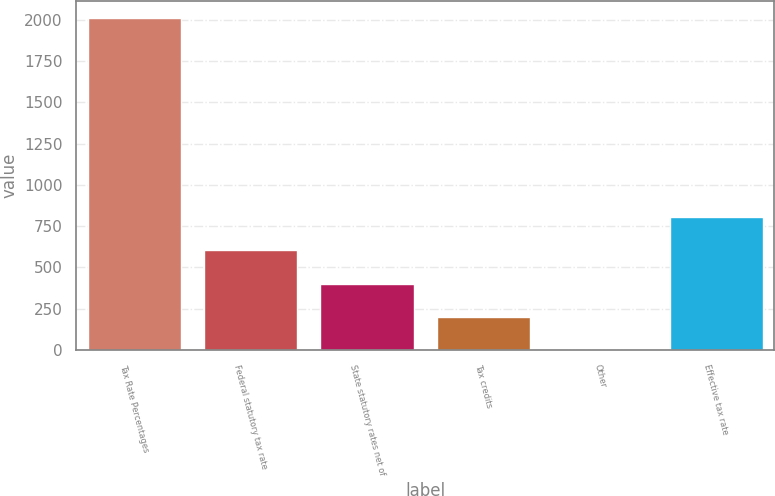<chart> <loc_0><loc_0><loc_500><loc_500><bar_chart><fcel>Tax Rate Percentages<fcel>Federal statutory tax rate<fcel>State statutory rates net of<fcel>Tax credits<fcel>Other<fcel>Effective tax rate<nl><fcel>2013<fcel>603.97<fcel>402.68<fcel>201.39<fcel>0.1<fcel>805.26<nl></chart> 